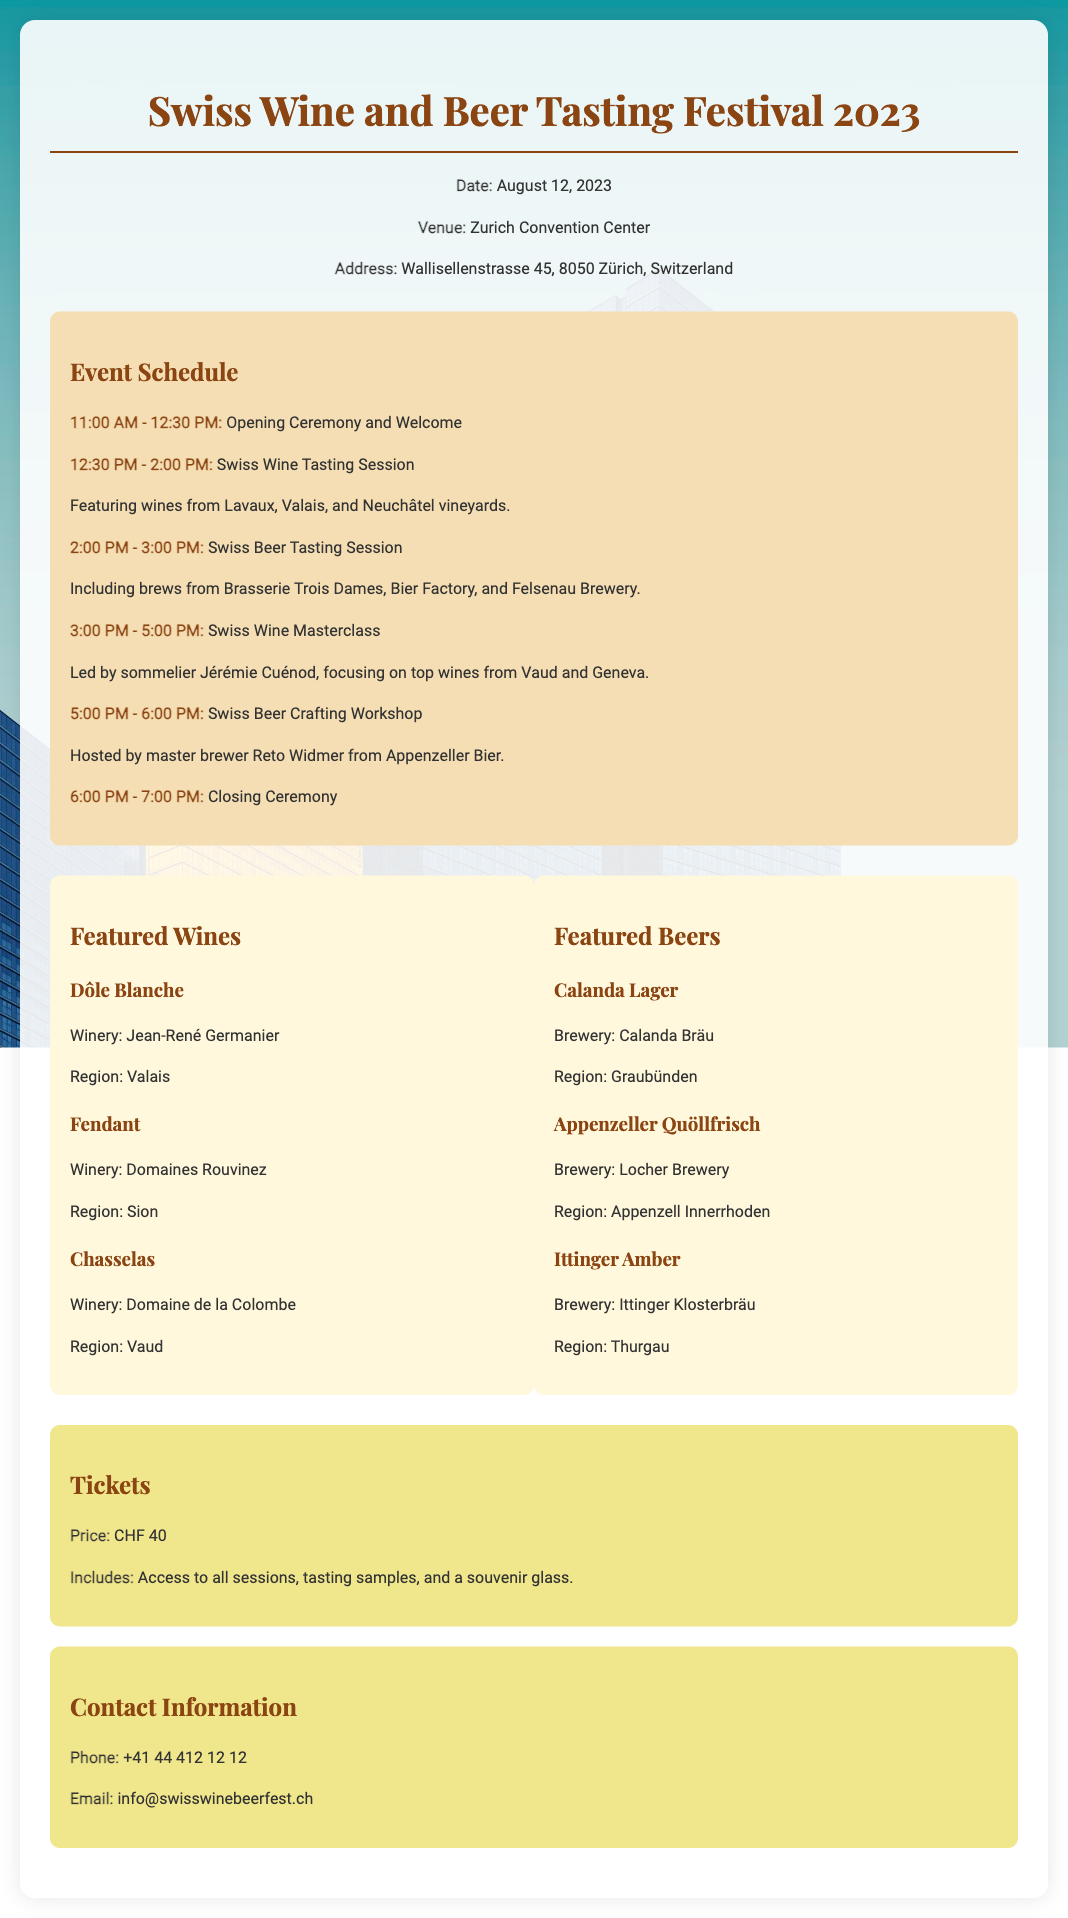What is the date of the event? The event date is specified in the document's event info section.
Answer: August 12, 2023 What is the venue for the festival? The venue is mentioned in the event info section of the document.
Answer: Zurich Convention Center Who is leading the Swiss Wine Masterclass? The document states the sommelier responsible for this session.
Answer: Jérémie Cuénod Which winery produces Dôle Blanche? The winery associated with Dôle Blanche is found in the featured wines section.
Answer: Jean-René Germanier How much do tickets cost? The ticket price is explicitly mentioned in the tickets section of the document.
Answer: CHF 40 What time does the Swiss Beer Tasting Session start? The schedule outlines the start time for this particular tasting session.
Answer: 2:00 PM Which brewery produces Appenzeller Quöllfrisch? The brewery responsible for this beer is listed in the featured beers section.
Answer: Locher Brewery What is included with the ticket purchase? The document details the inclusions in the tickets section.
Answer: Access to all sessions, tasting samples, and a souvenir glass What region is Chasselas from? The region of this wine is specified in the featured wines section.
Answer: Vaud 